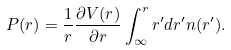Convert formula to latex. <formula><loc_0><loc_0><loc_500><loc_500>P ( r ) = \frac { 1 } { r } \frac { \partial V ( r ) } { \partial r } \int _ { \infty } ^ { r } r ^ { \prime } d r ^ { \prime } n ( r ^ { \prime } ) .</formula> 